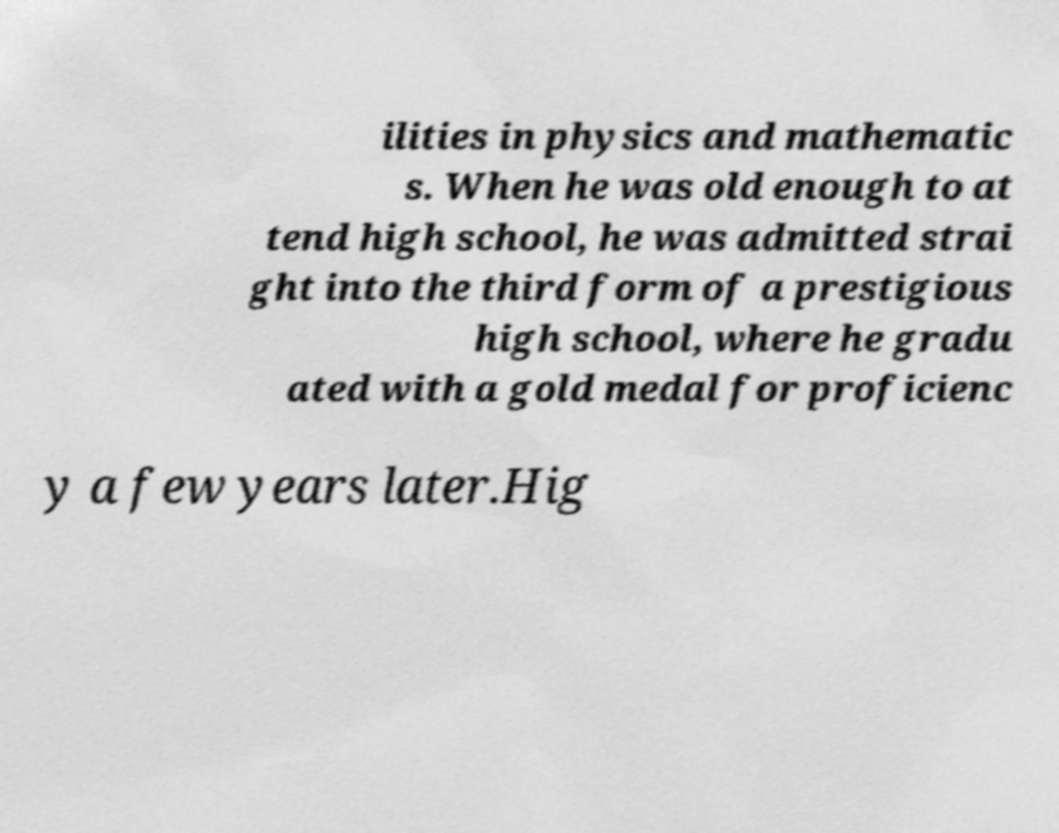For documentation purposes, I need the text within this image transcribed. Could you provide that? ilities in physics and mathematic s. When he was old enough to at tend high school, he was admitted strai ght into the third form of a prestigious high school, where he gradu ated with a gold medal for proficienc y a few years later.Hig 